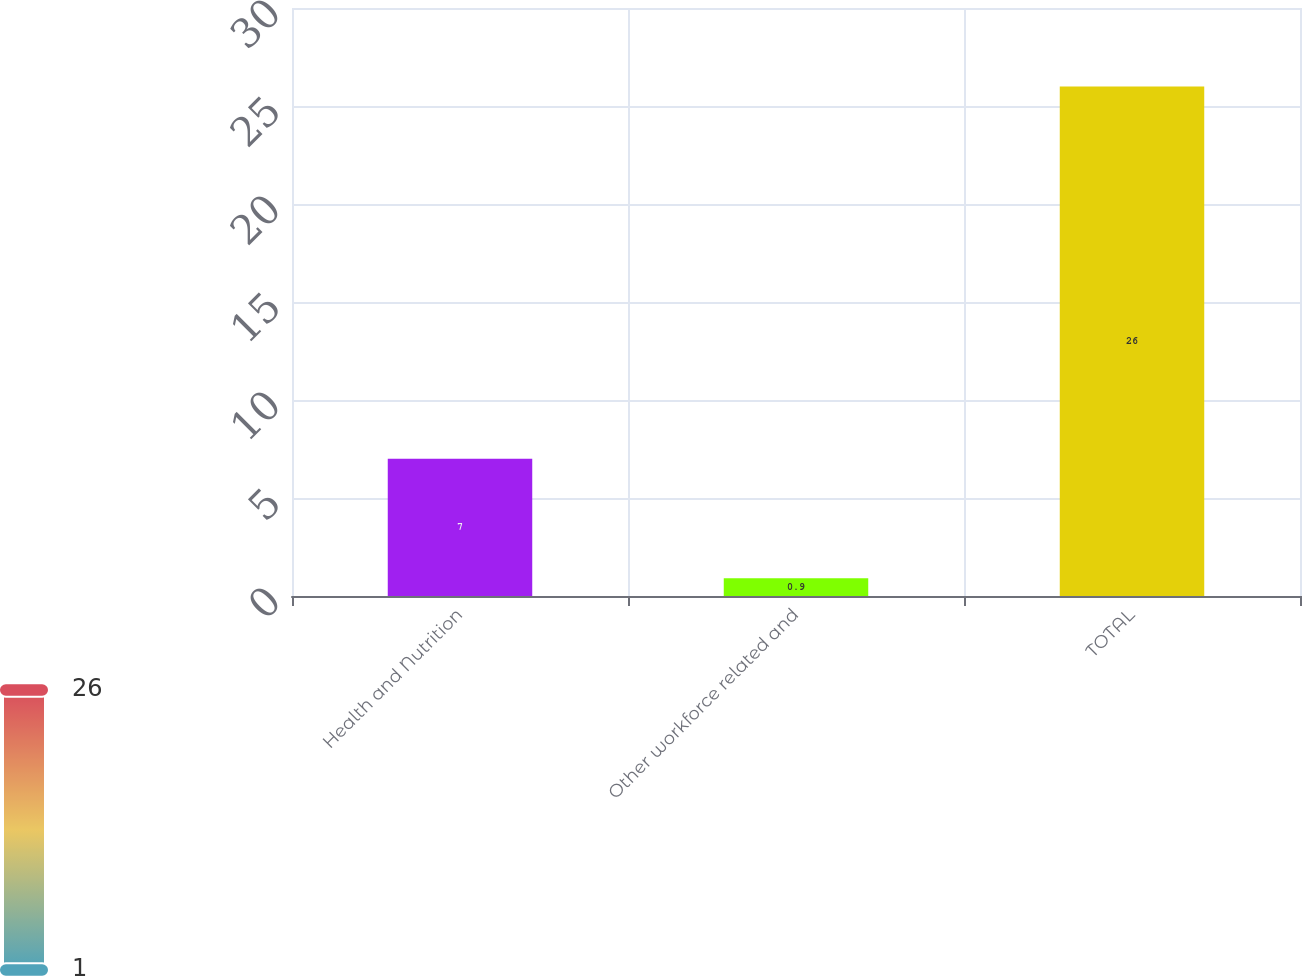Convert chart to OTSL. <chart><loc_0><loc_0><loc_500><loc_500><bar_chart><fcel>Health and Nutrition<fcel>Other workforce related and<fcel>TOTAL<nl><fcel>7<fcel>0.9<fcel>26<nl></chart> 